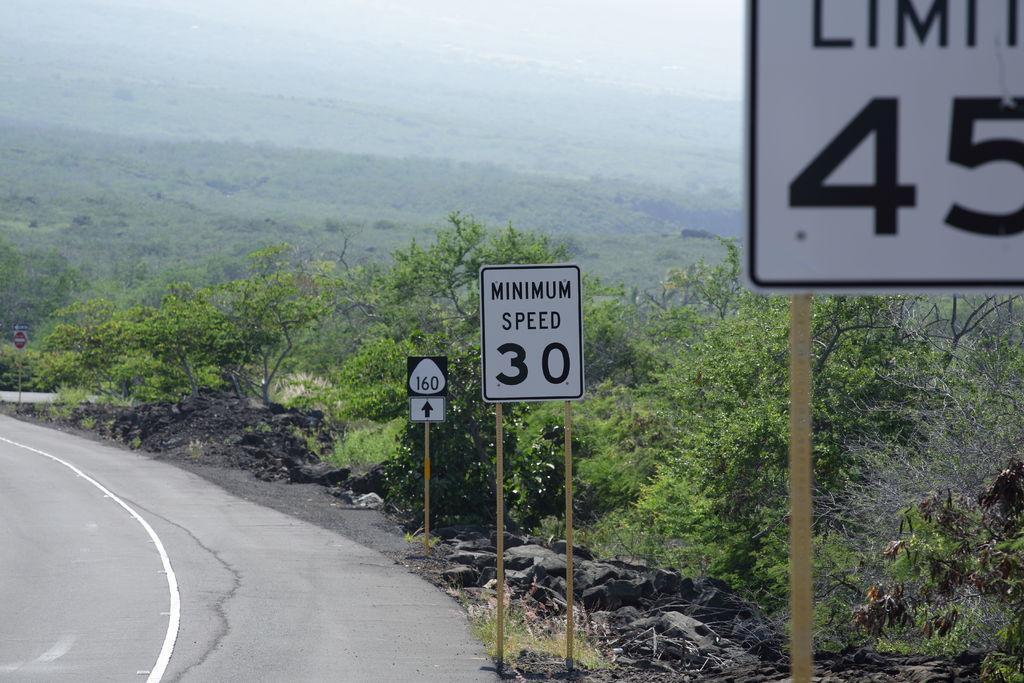How would you summarize this image in a sentence or two? In this image on the right there is a road. on the right there are many sign boards. In the background there are trees, hills. 